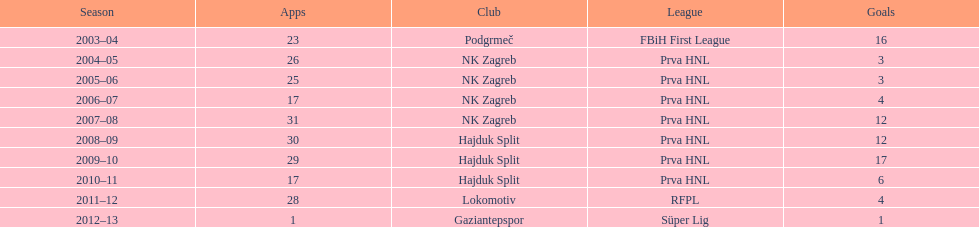The team with the most goals Hajduk Split. 